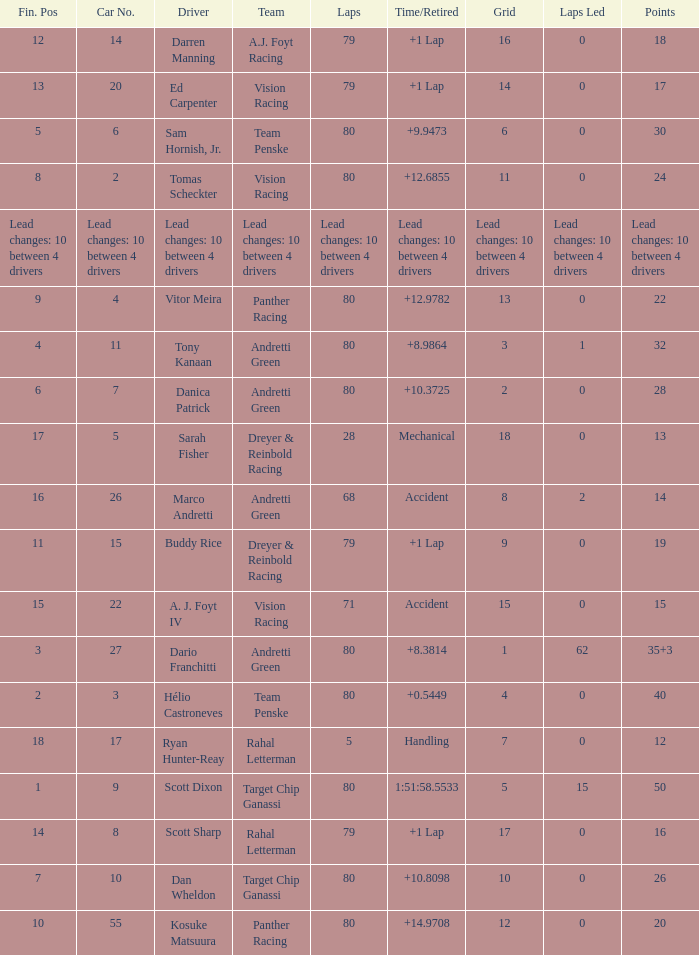Which group possesses 26 points? Target Chip Ganassi. 